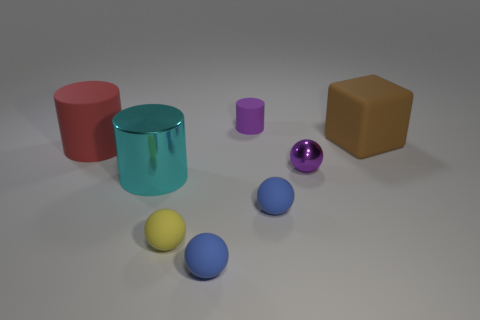What color is the tiny object behind the sphere that is behind the cyan cylinder?
Your answer should be compact. Purple. There is a red matte thing; what number of purple metal balls are on the left side of it?
Your answer should be compact. 0. What is the color of the small metallic thing?
Your response must be concise. Purple. What number of large objects are cyan things or rubber objects?
Ensure brevity in your answer.  3. Do the small object behind the tiny purple metallic ball and the rubber cylinder in front of the cube have the same color?
Ensure brevity in your answer.  No. What number of other things are there of the same color as the small shiny sphere?
Make the answer very short. 1. The rubber thing that is in front of the yellow rubber sphere has what shape?
Offer a very short reply. Sphere. Is the number of small purple matte cylinders less than the number of brown rubber cylinders?
Make the answer very short. No. Are the block that is behind the big cyan cylinder and the tiny purple cylinder made of the same material?
Keep it short and to the point. Yes. Is there any other thing that has the same size as the metallic ball?
Offer a terse response. Yes. 